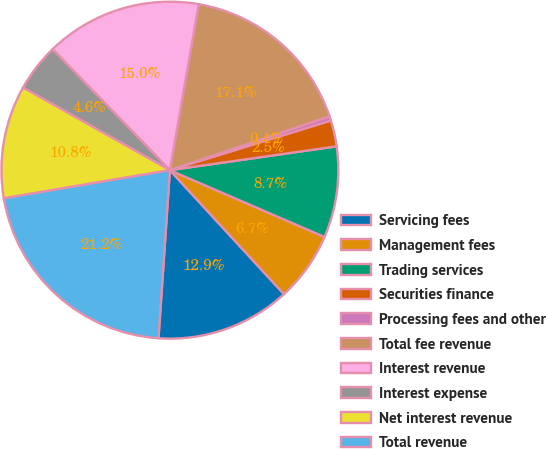Convert chart to OTSL. <chart><loc_0><loc_0><loc_500><loc_500><pie_chart><fcel>Servicing fees<fcel>Management fees<fcel>Trading services<fcel>Securities finance<fcel>Processing fees and other<fcel>Total fee revenue<fcel>Interest revenue<fcel>Interest expense<fcel>Net interest revenue<fcel>Total revenue<nl><fcel>12.92%<fcel>6.67%<fcel>8.75%<fcel>2.5%<fcel>0.42%<fcel>17.08%<fcel>15.0%<fcel>4.59%<fcel>10.83%<fcel>21.25%<nl></chart> 